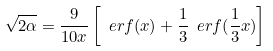Convert formula to latex. <formula><loc_0><loc_0><loc_500><loc_500>\sqrt { 2 \alpha } = \frac { 9 } { 1 0 x } \left [ \ e r f ( x ) + \frac { 1 } { 3 } \ e r f ( \frac { 1 } { 3 } x ) \right ]</formula> 